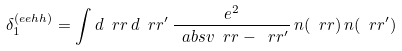<formula> <loc_0><loc_0><loc_500><loc_500>\delta _ { 1 } ^ { ( e e h h ) } = \int d \ r r \, d \ r r ^ { \prime } \, \frac { e ^ { 2 } } { \ a b s v { \ r r - \ r r ^ { \prime } } } \, n ( \ r r ) \, n ( \ r r ^ { \prime } )</formula> 